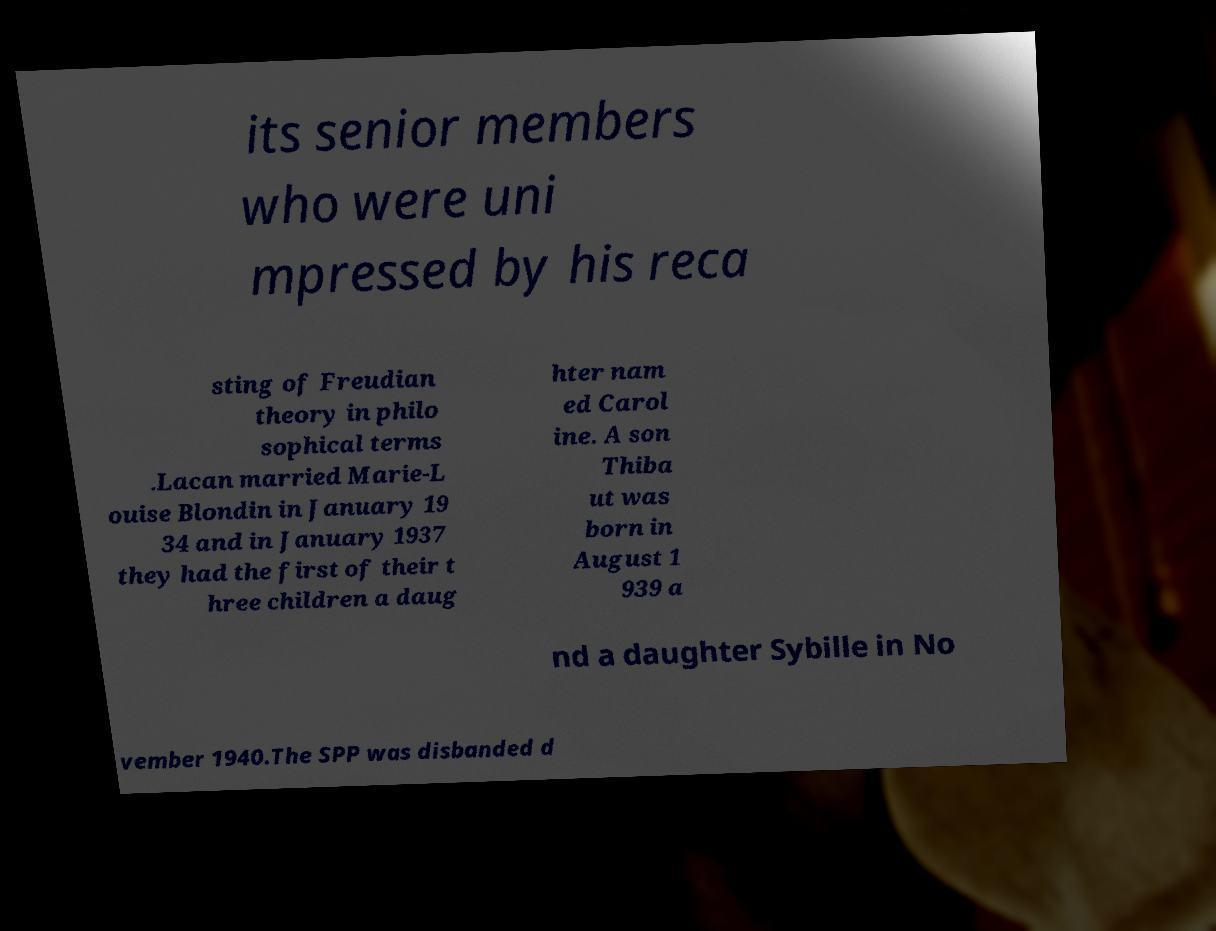Can you read and provide the text displayed in the image?This photo seems to have some interesting text. Can you extract and type it out for me? its senior members who were uni mpressed by his reca sting of Freudian theory in philo sophical terms .Lacan married Marie-L ouise Blondin in January 19 34 and in January 1937 they had the first of their t hree children a daug hter nam ed Carol ine. A son Thiba ut was born in August 1 939 a nd a daughter Sybille in No vember 1940.The SPP was disbanded d 